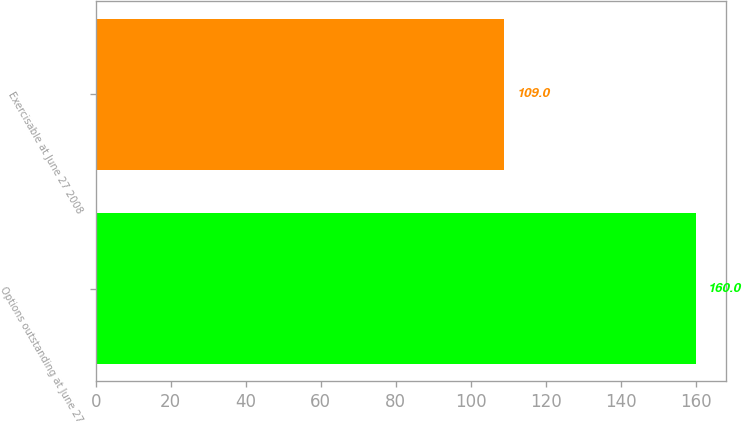Convert chart. <chart><loc_0><loc_0><loc_500><loc_500><bar_chart><fcel>Options outstanding at June 27<fcel>Exercisable at June 27 2008<nl><fcel>160<fcel>109<nl></chart> 